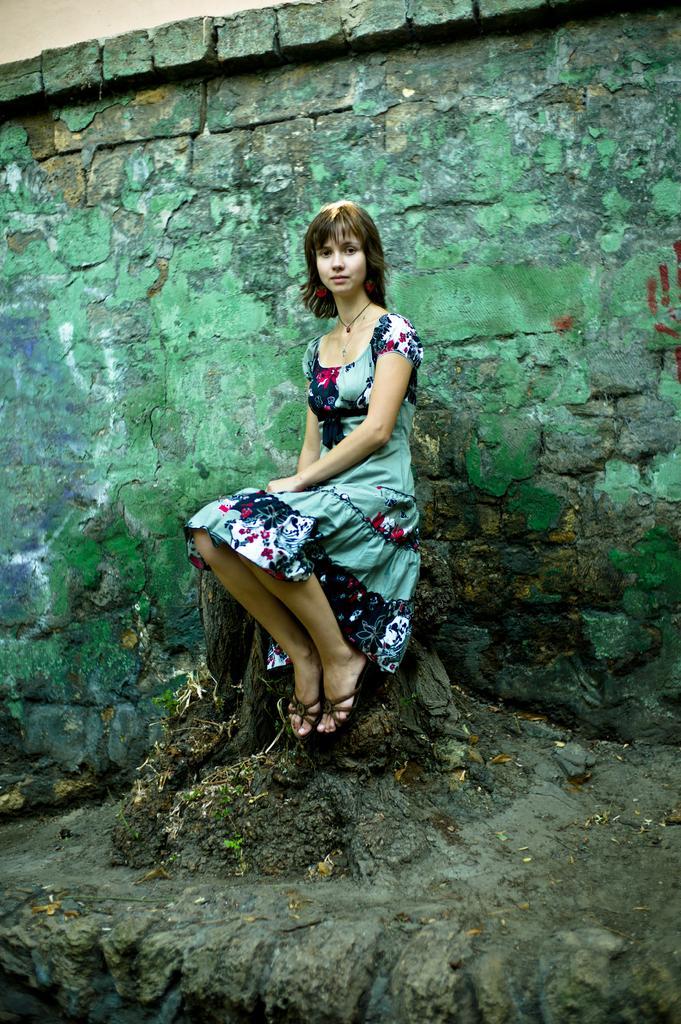Could you give a brief overview of what you see in this image? A girl is sitting on a tree trunk. Behind her there is a brick wall. 